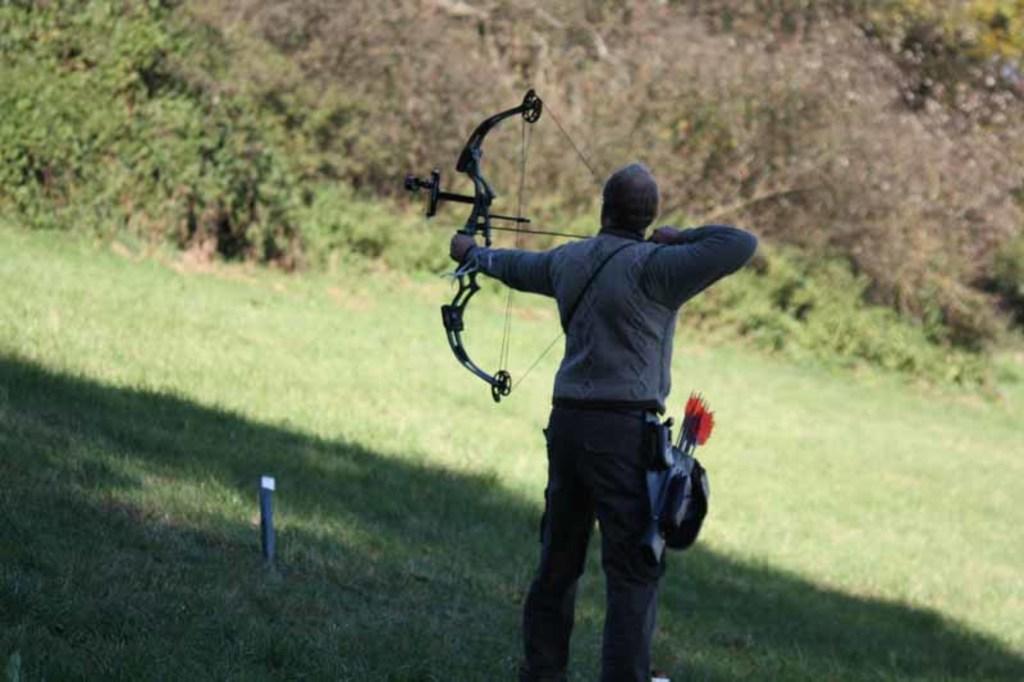Describe this image in one or two sentences. In this image, we can see a person wearing clothes and shooting an arrow. There are some plants at the top of the image. 